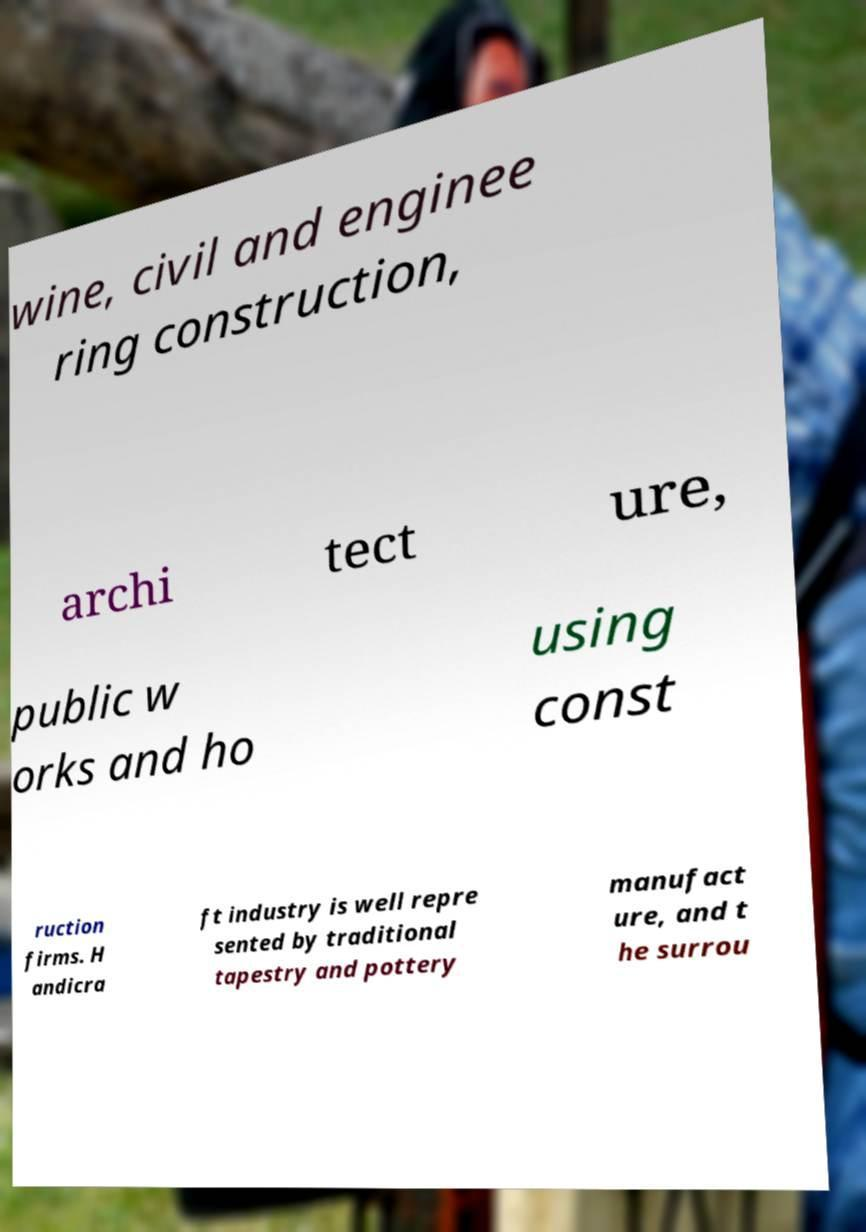Please read and relay the text visible in this image. What does it say? wine, civil and enginee ring construction, archi tect ure, public w orks and ho using const ruction firms. H andicra ft industry is well repre sented by traditional tapestry and pottery manufact ure, and t he surrou 